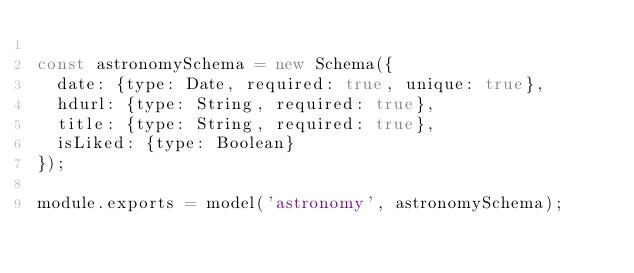Convert code to text. <code><loc_0><loc_0><loc_500><loc_500><_JavaScript_>
const astronomySchema = new Schema({
  date: {type: Date, required: true, unique: true},
  hdurl: {type: String, required: true},
  title: {type: String, required: true},
  isLiked: {type: Boolean}
});

module.exports = model('astronomy', astronomySchema);


</code> 